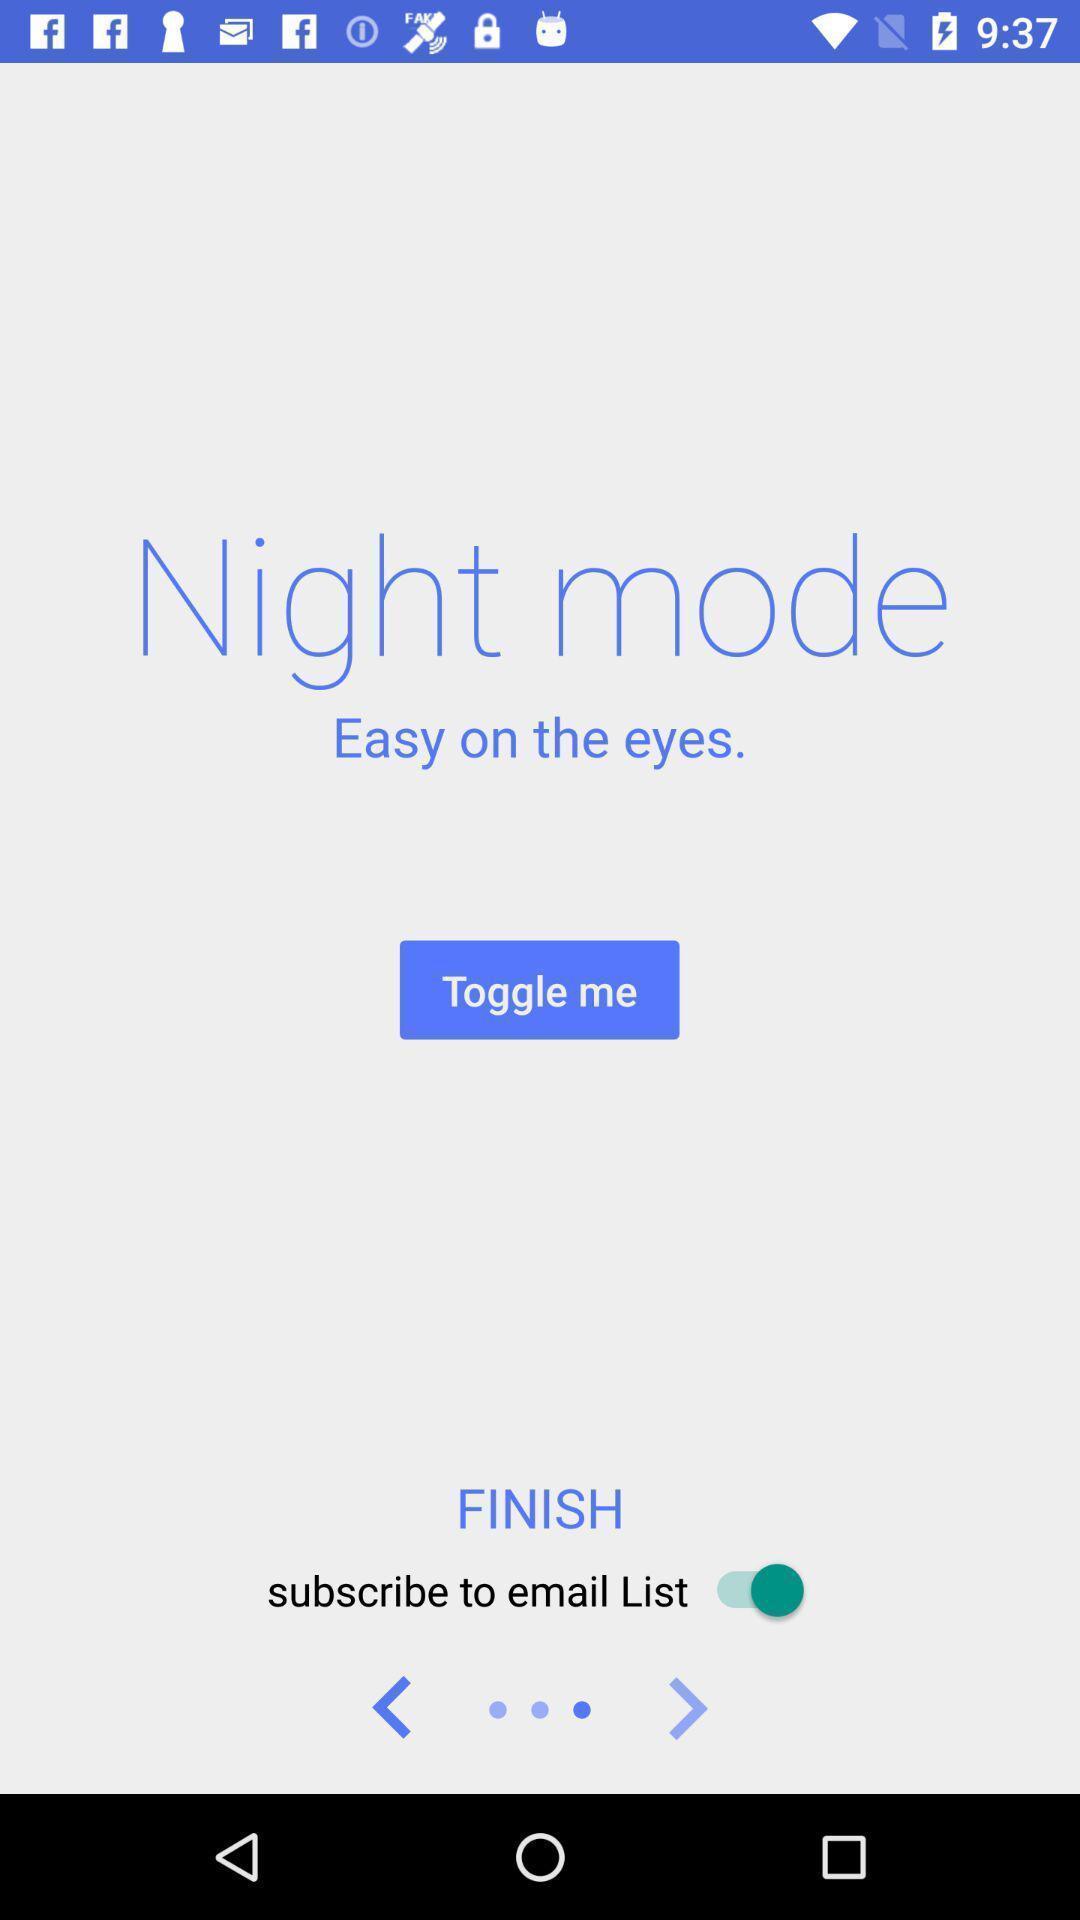What details can you identify in this image? Welcome page. 